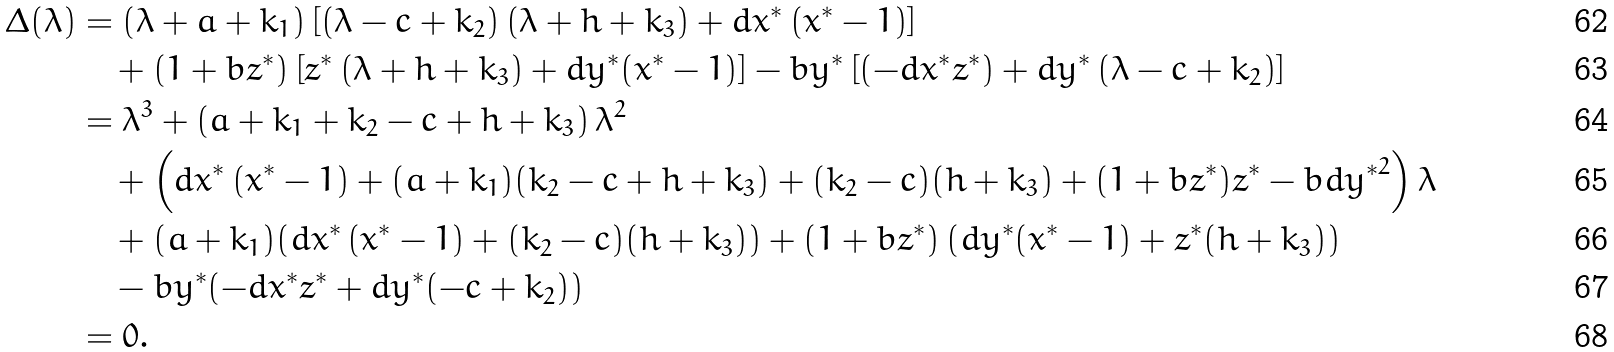<formula> <loc_0><loc_0><loc_500><loc_500>\Delta ( \lambda ) & = \left ( { \lambda + a + { k _ { 1 } } } \right ) \left [ { \left ( { \lambda - c + { k _ { 2 } } } \right ) \left ( { \lambda + h + { k _ { 3 } } } \right ) + d { x ^ { * } } \left ( { { x ^ { * } } - 1 } \right ) } \right ] \\ & \quad + \left ( { 1 + b { z ^ { * } } } \right ) \left [ { { z ^ { * } } \left ( { \lambda + h + { k _ { 3 } } } \right ) + d { y ^ { * } } ( { x ^ { * } } - 1 ) } \right ] - b { y ^ { * } } \left [ { \left ( { - d { x ^ { * } } { z ^ { * } } } \right ) + d { y ^ { * } } \left ( { \lambda - c + { k _ { 2 } } } \right ) } \right ] \\ & = { \lambda ^ { 3 } } + \left ( { a + { k _ { 1 } } + { k _ { 2 } } - c + h + { k _ { 3 } } } \right ) { \lambda ^ { 2 } } \\ & \quad + \left ( { d { x ^ { * } } \left ( { { x ^ { * } } - 1 } \right ) + ( a + { k _ { 1 } } ) ( { k _ { 2 } } - c + h + { k _ { 3 } } ) + ( { k _ { 2 } } - c ) ( h + { k _ { 3 } } ) + ( 1 + b { z ^ { * } } ) { z ^ { * } } - b d { y ^ { * } } ^ { 2 } } \right ) \lambda \\ & \quad + ( a + { k _ { 1 } } ) ( d { x ^ { * } } \left ( { { x ^ { * } } - 1 } \right ) + ( { k _ { 2 } } - c ) ( h + { k _ { 3 } } ) ) + \left ( { 1 + b { z ^ { * } } } \right ) ( d { y ^ { * } } ( { x ^ { * } } - 1 ) + { z ^ { * } } ( h + { k _ { 3 } } ) ) \\ & \quad - b { y ^ { * } } ( - d { x ^ { * } } { z ^ { * } } + d { y ^ { * } } ( - c + { k _ { 2 } } ) ) \\ & = 0 .</formula> 